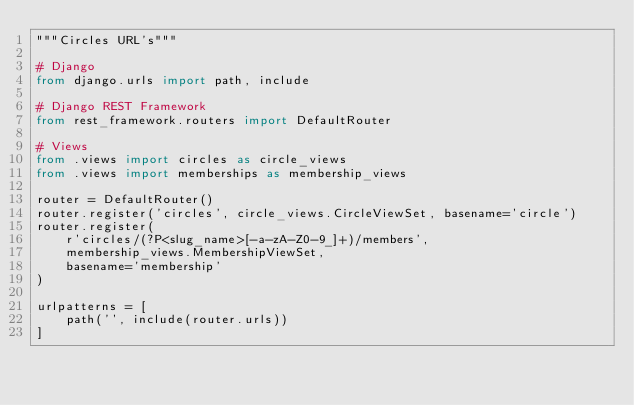Convert code to text. <code><loc_0><loc_0><loc_500><loc_500><_Python_>"""Circles URL's"""

# Django
from django.urls import path, include

# Django REST Framework
from rest_framework.routers import DefaultRouter

# Views
from .views import circles as circle_views
from .views import memberships as membership_views

router = DefaultRouter()
router.register('circles', circle_views.CircleViewSet, basename='circle')
router.register(
    r'circles/(?P<slug_name>[-a-zA-Z0-9_]+)/members',
    membership_views.MembershipViewSet,
    basename='membership'
)

urlpatterns = [
    path('', include(router.urls))
]
</code> 